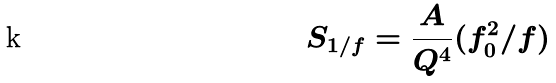Convert formula to latex. <formula><loc_0><loc_0><loc_500><loc_500>S _ { 1 / f } = \frac { A } { Q ^ { 4 } } ( f _ { 0 } ^ { 2 } / f )</formula> 